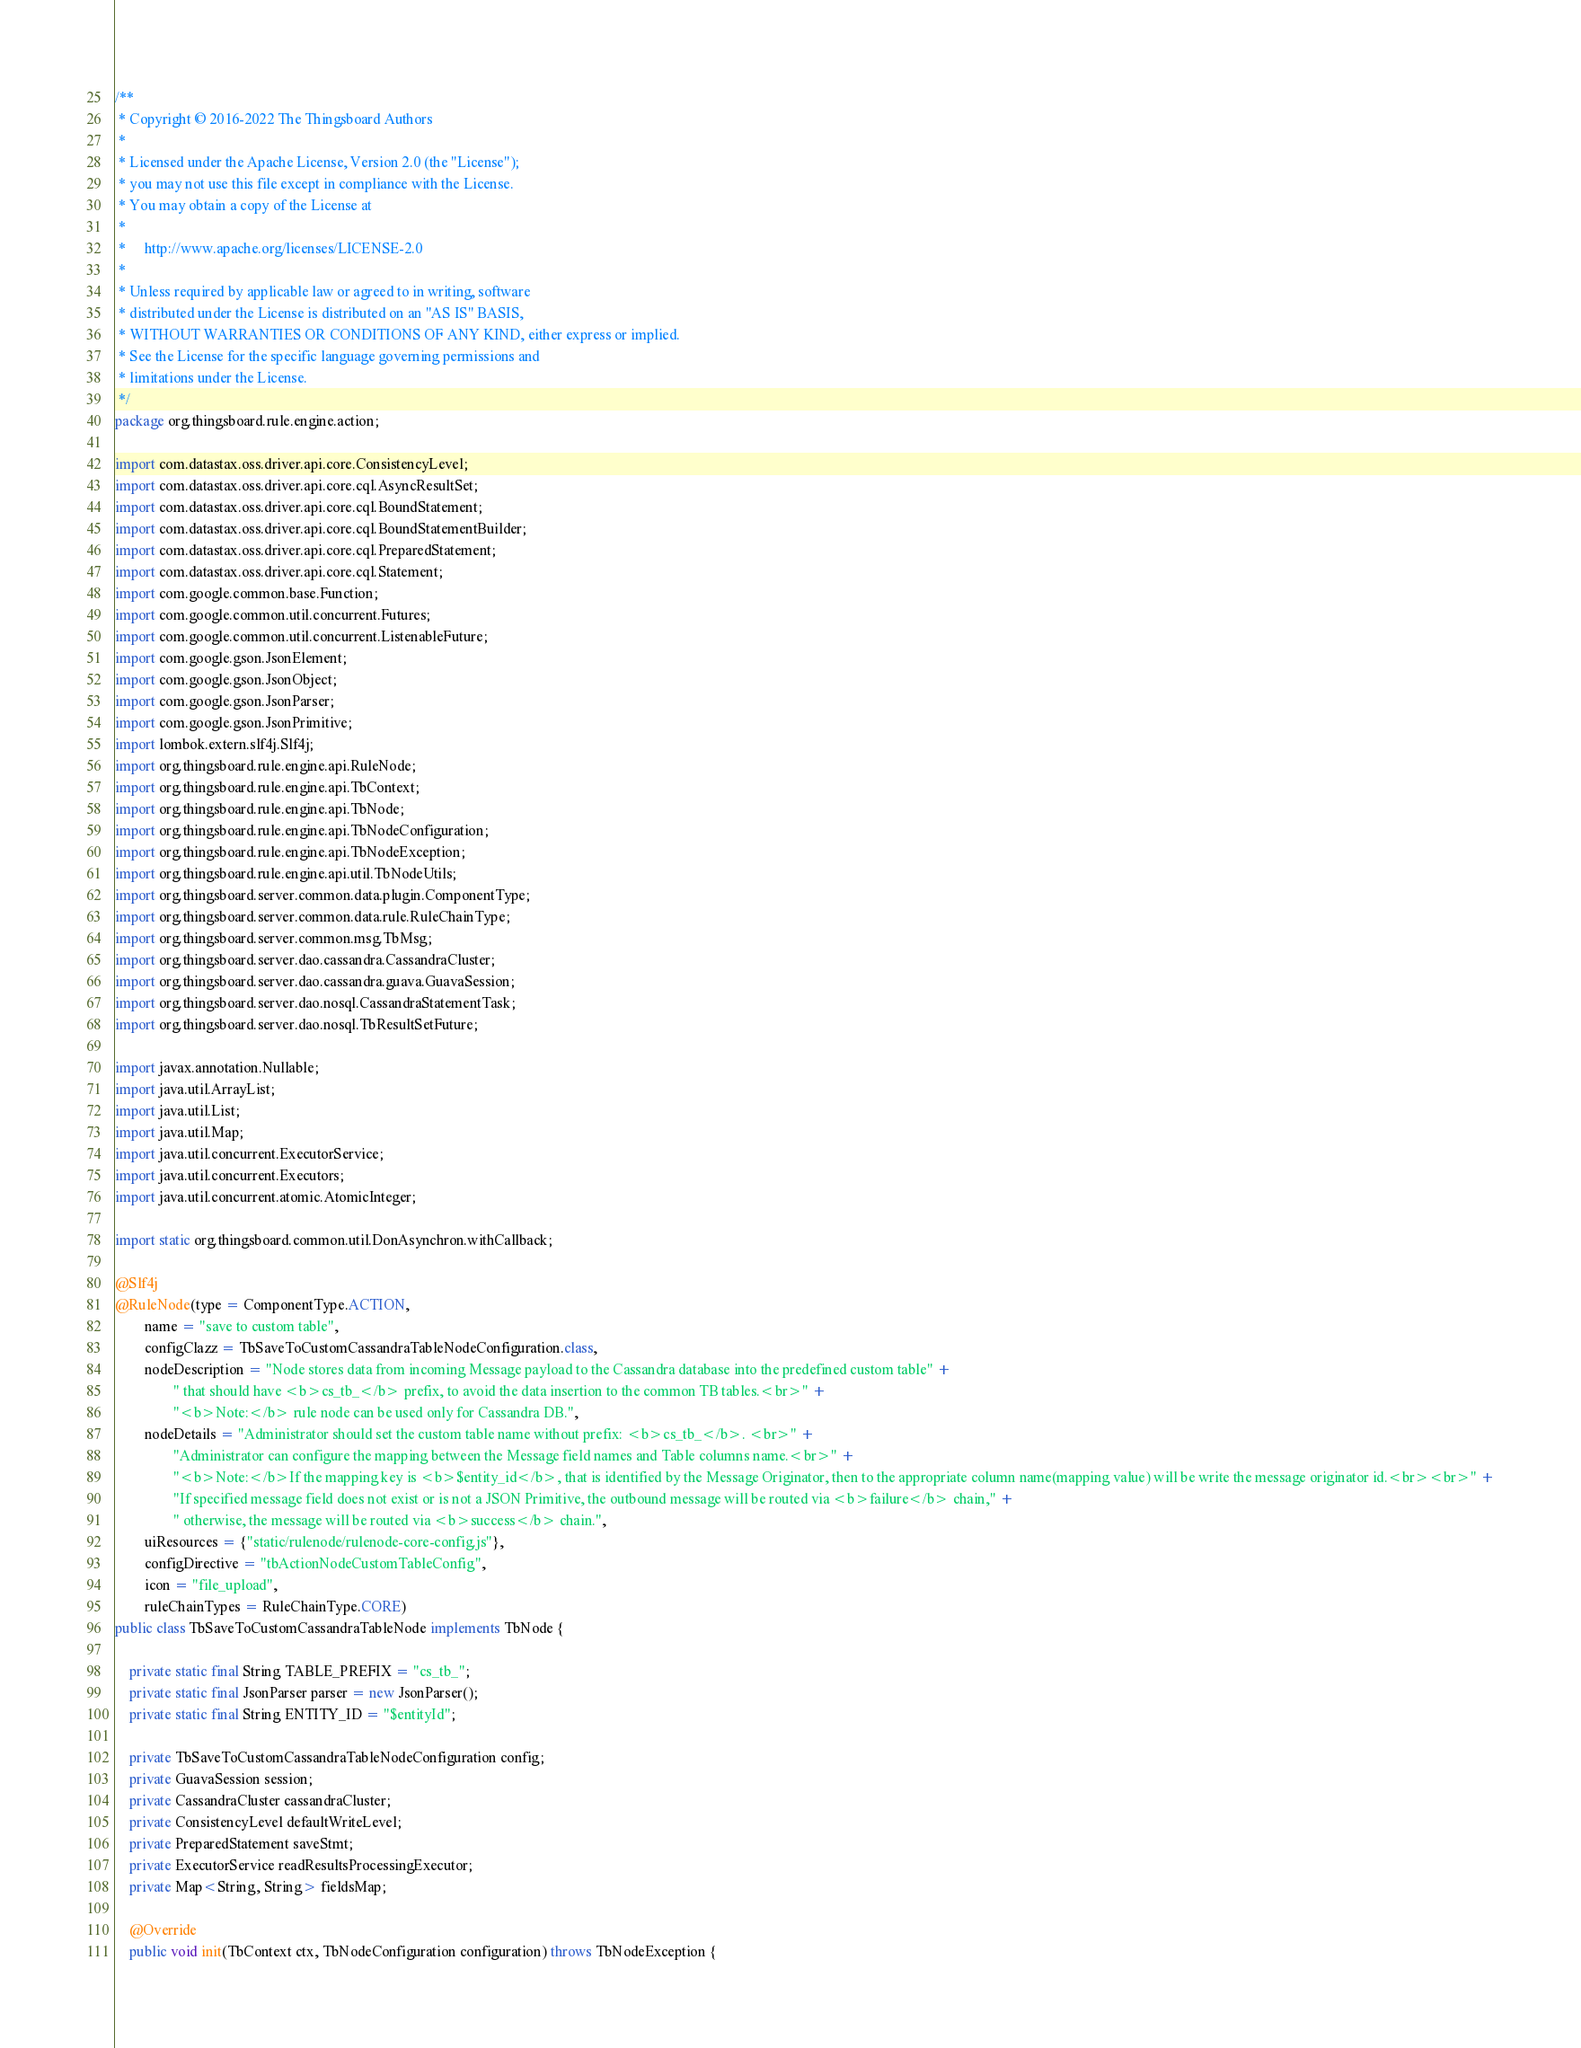<code> <loc_0><loc_0><loc_500><loc_500><_Java_>/**
 * Copyright © 2016-2022 The Thingsboard Authors
 *
 * Licensed under the Apache License, Version 2.0 (the "License");
 * you may not use this file except in compliance with the License.
 * You may obtain a copy of the License at
 *
 *     http://www.apache.org/licenses/LICENSE-2.0
 *
 * Unless required by applicable law or agreed to in writing, software
 * distributed under the License is distributed on an "AS IS" BASIS,
 * WITHOUT WARRANTIES OR CONDITIONS OF ANY KIND, either express or implied.
 * See the License for the specific language governing permissions and
 * limitations under the License.
 */
package org.thingsboard.rule.engine.action;

import com.datastax.oss.driver.api.core.ConsistencyLevel;
import com.datastax.oss.driver.api.core.cql.AsyncResultSet;
import com.datastax.oss.driver.api.core.cql.BoundStatement;
import com.datastax.oss.driver.api.core.cql.BoundStatementBuilder;
import com.datastax.oss.driver.api.core.cql.PreparedStatement;
import com.datastax.oss.driver.api.core.cql.Statement;
import com.google.common.base.Function;
import com.google.common.util.concurrent.Futures;
import com.google.common.util.concurrent.ListenableFuture;
import com.google.gson.JsonElement;
import com.google.gson.JsonObject;
import com.google.gson.JsonParser;
import com.google.gson.JsonPrimitive;
import lombok.extern.slf4j.Slf4j;
import org.thingsboard.rule.engine.api.RuleNode;
import org.thingsboard.rule.engine.api.TbContext;
import org.thingsboard.rule.engine.api.TbNode;
import org.thingsboard.rule.engine.api.TbNodeConfiguration;
import org.thingsboard.rule.engine.api.TbNodeException;
import org.thingsboard.rule.engine.api.util.TbNodeUtils;
import org.thingsboard.server.common.data.plugin.ComponentType;
import org.thingsboard.server.common.data.rule.RuleChainType;
import org.thingsboard.server.common.msg.TbMsg;
import org.thingsboard.server.dao.cassandra.CassandraCluster;
import org.thingsboard.server.dao.cassandra.guava.GuavaSession;
import org.thingsboard.server.dao.nosql.CassandraStatementTask;
import org.thingsboard.server.dao.nosql.TbResultSetFuture;

import javax.annotation.Nullable;
import java.util.ArrayList;
import java.util.List;
import java.util.Map;
import java.util.concurrent.ExecutorService;
import java.util.concurrent.Executors;
import java.util.concurrent.atomic.AtomicInteger;

import static org.thingsboard.common.util.DonAsynchron.withCallback;

@Slf4j
@RuleNode(type = ComponentType.ACTION,
        name = "save to custom table",
        configClazz = TbSaveToCustomCassandraTableNodeConfiguration.class,
        nodeDescription = "Node stores data from incoming Message payload to the Cassandra database into the predefined custom table" +
                " that should have <b>cs_tb_</b> prefix, to avoid the data insertion to the common TB tables.<br>" +
                "<b>Note:</b> rule node can be used only for Cassandra DB.",
        nodeDetails = "Administrator should set the custom table name without prefix: <b>cs_tb_</b>. <br>" +
                "Administrator can configure the mapping between the Message field names and Table columns name.<br>" +
                "<b>Note:</b>If the mapping key is <b>$entity_id</b>, that is identified by the Message Originator, then to the appropriate column name(mapping value) will be write the message originator id.<br><br>" +
                "If specified message field does not exist or is not a JSON Primitive, the outbound message will be routed via <b>failure</b> chain," +
                " otherwise, the message will be routed via <b>success</b> chain.",
        uiResources = {"static/rulenode/rulenode-core-config.js"},
        configDirective = "tbActionNodeCustomTableConfig",
        icon = "file_upload",
        ruleChainTypes = RuleChainType.CORE)
public class TbSaveToCustomCassandraTableNode implements TbNode {

    private static final String TABLE_PREFIX = "cs_tb_";
    private static final JsonParser parser = new JsonParser();
    private static final String ENTITY_ID = "$entityId";

    private TbSaveToCustomCassandraTableNodeConfiguration config;
    private GuavaSession session;
    private CassandraCluster cassandraCluster;
    private ConsistencyLevel defaultWriteLevel;
    private PreparedStatement saveStmt;
    private ExecutorService readResultsProcessingExecutor;
    private Map<String, String> fieldsMap;

    @Override
    public void init(TbContext ctx, TbNodeConfiguration configuration) throws TbNodeException {</code> 